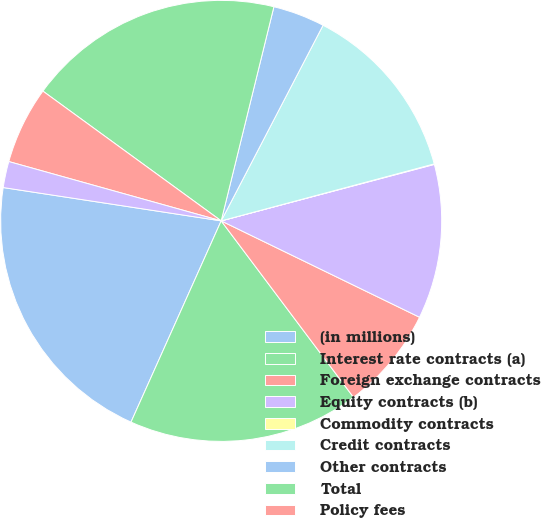Convert chart. <chart><loc_0><loc_0><loc_500><loc_500><pie_chart><fcel>(in millions)<fcel>Interest rate contracts (a)<fcel>Foreign exchange contracts<fcel>Equity contracts (b)<fcel>Commodity contracts<fcel>Credit contracts<fcel>Other contracts<fcel>Total<fcel>Policy fees<fcel>Net investment income<nl><fcel>20.71%<fcel>16.95%<fcel>7.56%<fcel>11.32%<fcel>0.04%<fcel>13.2%<fcel>3.8%<fcel>18.83%<fcel>5.68%<fcel>1.92%<nl></chart> 